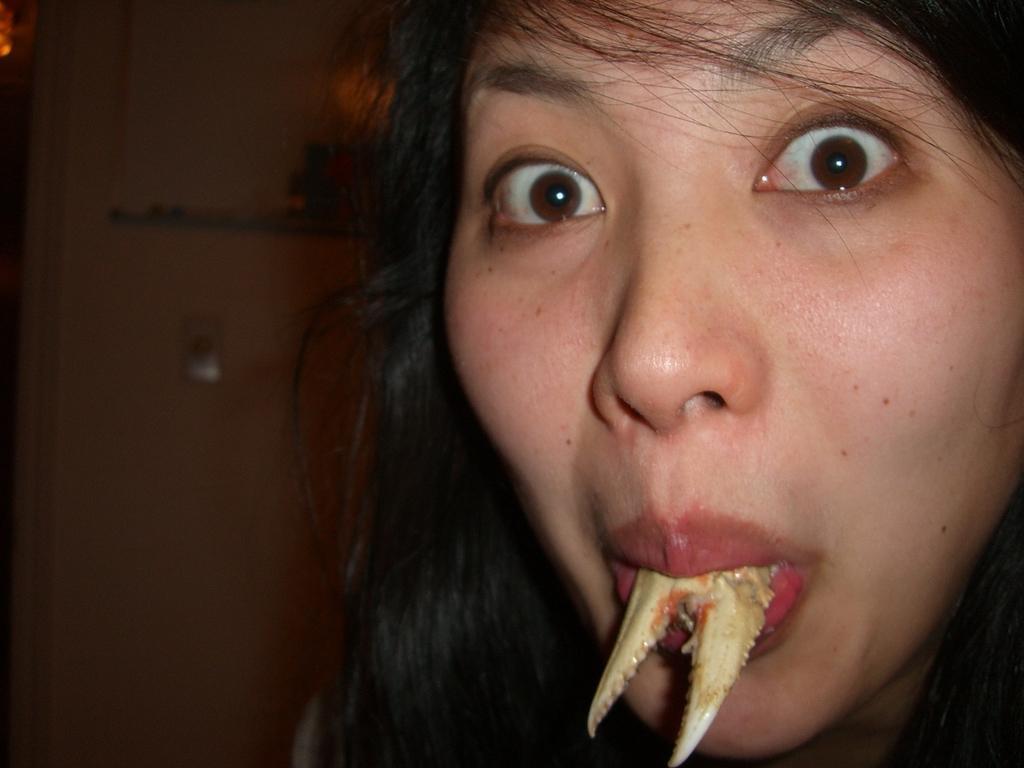Describe this image in one or two sentences. In this image I can see the person and I can see some object inside the mouth of the person and I can see the dark background. 